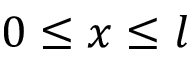Convert formula to latex. <formula><loc_0><loc_0><loc_500><loc_500>0 \leq x \leq l</formula> 